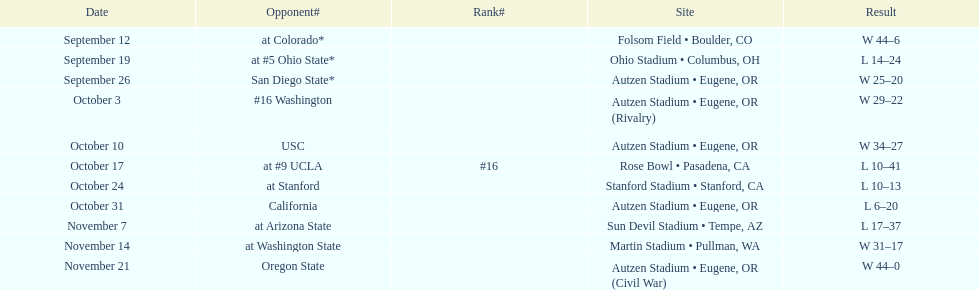How many away games are there? 6. 